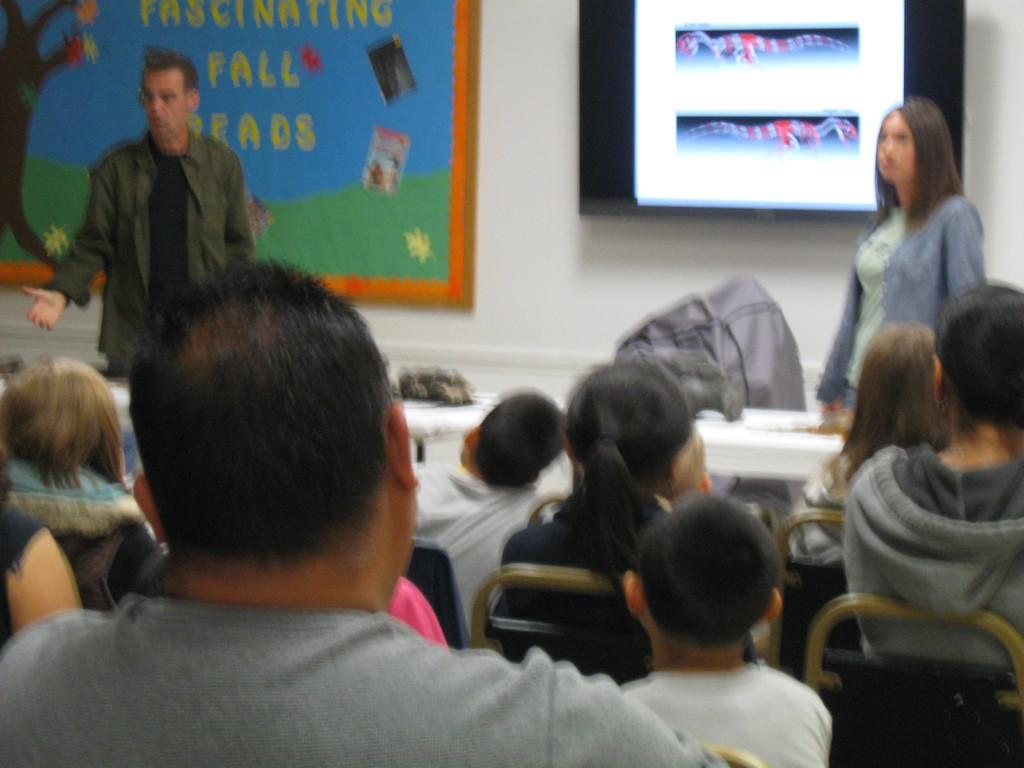What are the people in the image doing? The people in the image are sitting on chairs. Are there any other individuals visible in the image? Yes, there is a man and a lady standing in the background of the image. What can be seen on the wall in the image? There are boards placed on the wall in the image. What type of tongue can be seen sticking out of the man's mouth in the image? There is no tongue visible in the image, and the man's mouth is not shown. In which room is the scene taking place? The provided facts do not mention a room, so it cannot be determined from the image. 